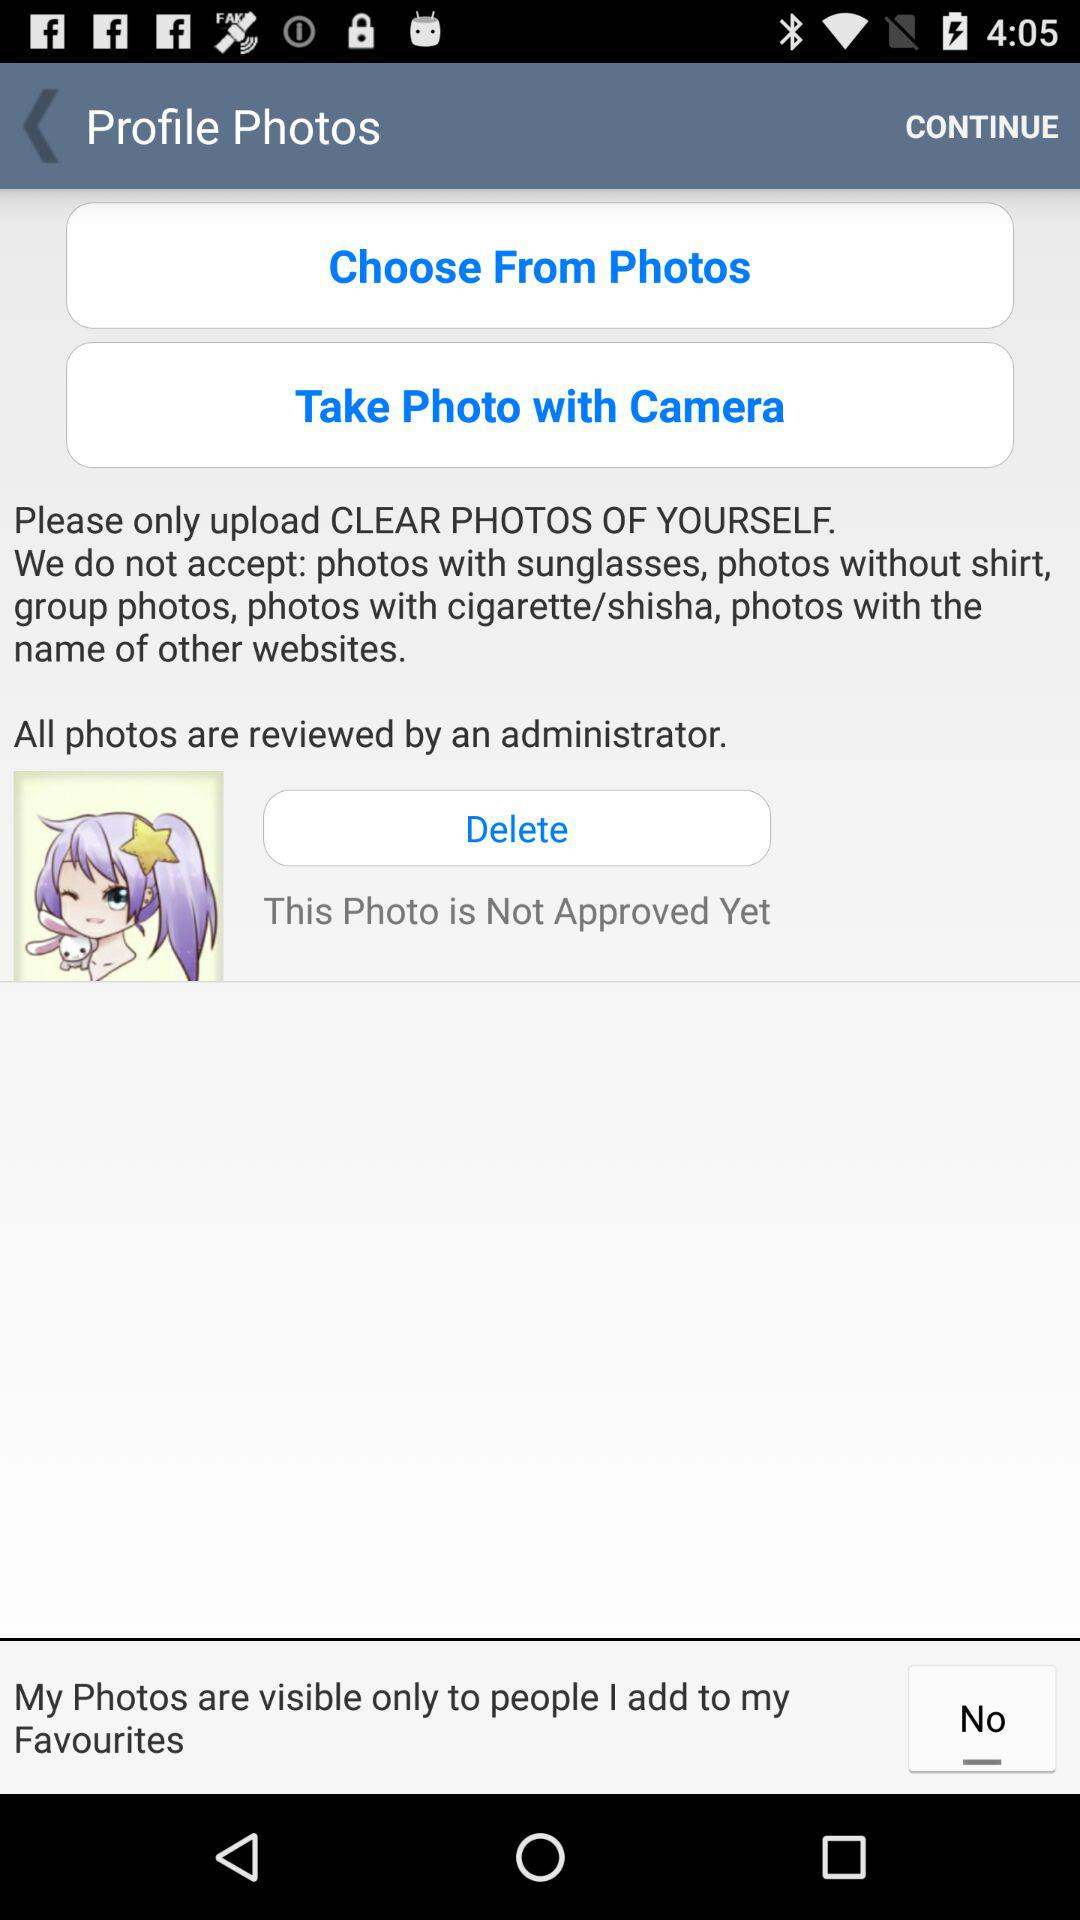How many photos are shown on the screen?
Answer the question using a single word or phrase. 1 